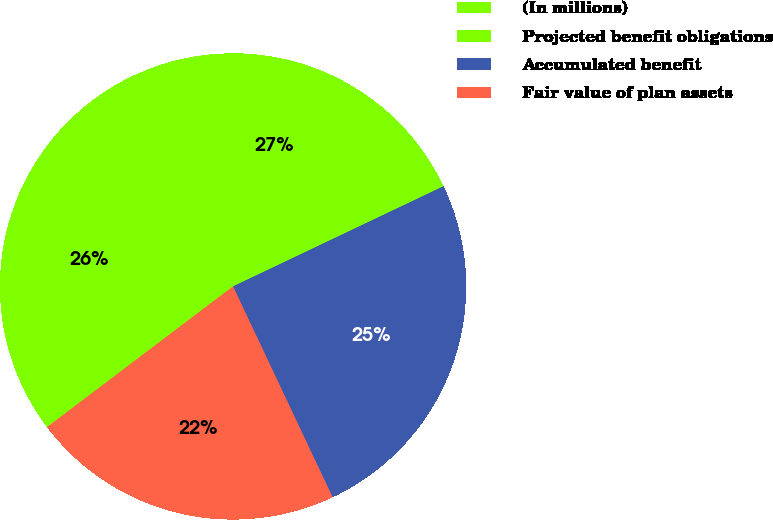Convert chart. <chart><loc_0><loc_0><loc_500><loc_500><pie_chart><fcel>(In millions)<fcel>Projected benefit obligations<fcel>Accumulated benefit<fcel>Fair value of plan assets<nl><fcel>26.38%<fcel>26.86%<fcel>25.05%<fcel>21.71%<nl></chart> 